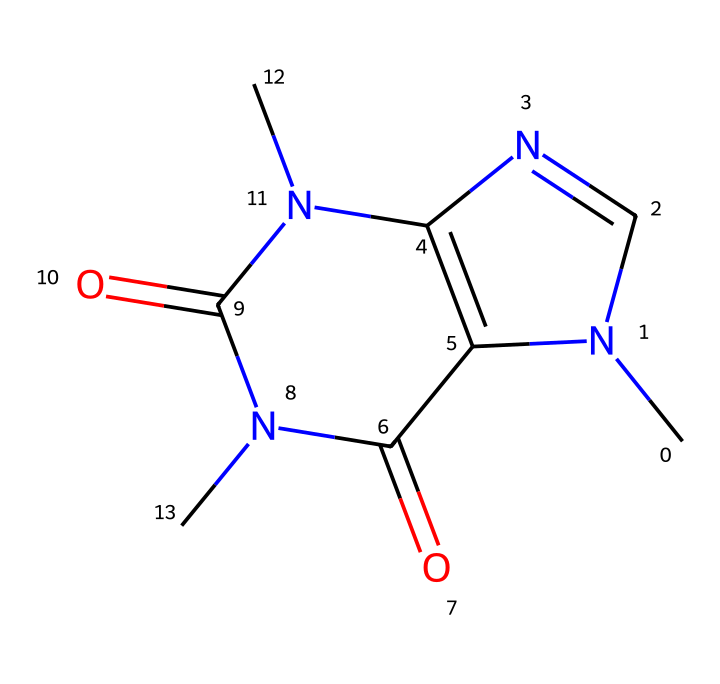What is the molecular formula of this compound? To derive the molecular formula, we identify the elements in the SMILES. The SMILES indicates there are 8 Carbon (C), 10 Hydrogen (H), 4 Nitrogen (N), and 2 Oxygen (O) atoms. This gives us the formula C8H10N4O2.
Answer: C8H10N4O2 How many nitrogen atoms are present in the structure? By analyzing the SMILES representation, we can count the nitrogen atoms noted by "N." There are 4 occurrences of nitrogen, indicating the presence of 4 nitrogen atoms in the structure.
Answer: 4 What structural feature indicates this compound is an alkaloid? The presence of the nitrogen atoms (N) within the ring structure and their arrangement is a key feature of alkaloids. Alkaloids are known for containing basic nitrogen, which this compound has.
Answer: nitrogen atoms What is the significance of the carbonyl groups in this structure? The carbonyl groups (C=O) contribute to various functional properties such as solubility and reactivity of the compound. In this case, they might enhance stimulatory effects and impact the overall bioactivity, typical in performance-enhancing compounds.
Answer: bioactivity Which type of chemical bonding is primarily present in this compound? The primary type of bonding in this compound is covalent bonding, as indicated by the sharing of electrons between atoms (C, H, N, O). This is a defining characteristic of organic molecules, including caffeine.
Answer: covalent bonding How does this compound interact with the adenosine receptors in the brain? This compound, caffeine, acts as a competitive antagonist at the adenosine receptors. It structurally mimics adenosine, allowing it to bind and block receptor activation, which is key to its stimulant properties.
Answer: antagonist What is the effect of this compound on athletic performance? The compound is known to enhance alertness and reduce perceived effort in players, improving focus and reaction time. This has made caffeine a popular choice among athletes looking to boost performance.
Answer: enhance alertness 